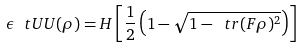Convert formula to latex. <formula><loc_0><loc_0><loc_500><loc_500>\epsilon _ { \ } t U U ( \rho ) = H \left [ \frac { 1 } { 2 } \left ( 1 - \sqrt { 1 - \ t r ( F \rho ) ^ { 2 } } \right ) \right ]</formula> 